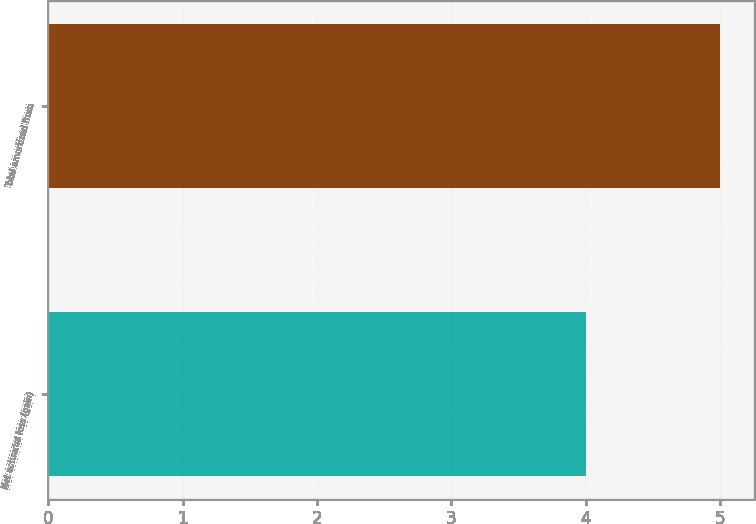Convert chart to OTSL. <chart><loc_0><loc_0><loc_500><loc_500><bar_chart><fcel>Net actuarial loss (gain)<fcel>Total amortized from<nl><fcel>4<fcel>5<nl></chart> 